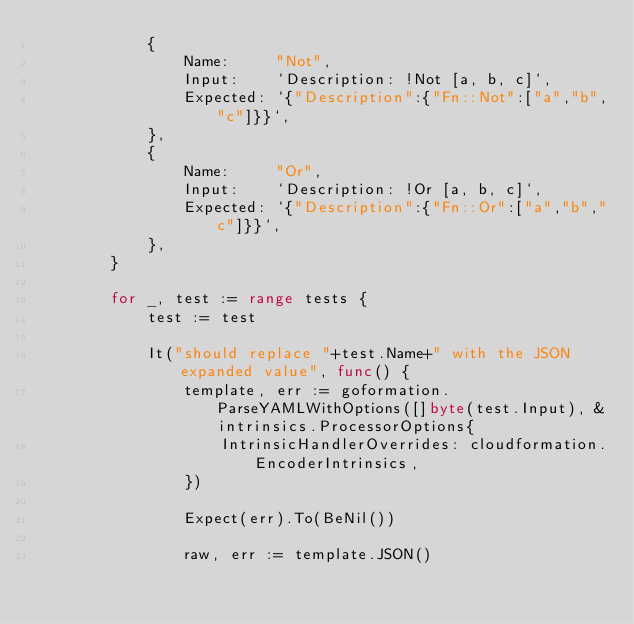Convert code to text. <code><loc_0><loc_0><loc_500><loc_500><_Go_>			{
				Name:     "Not",
				Input:    `Description: !Not [a, b, c]`,
				Expected: `{"Description":{"Fn::Not":["a","b","c"]}}`,
			},
			{
				Name:     "Or",
				Input:    `Description: !Or [a, b, c]`,
				Expected: `{"Description":{"Fn::Or":["a","b","c"]}}`,
			},
		}

		for _, test := range tests {
			test := test

			It("should replace "+test.Name+" with the JSON expanded value", func() {
				template, err := goformation.ParseYAMLWithOptions([]byte(test.Input), &intrinsics.ProcessorOptions{
					IntrinsicHandlerOverrides: cloudformation.EncoderIntrinsics,
				})

				Expect(err).To(BeNil())

				raw, err := template.JSON()</code> 